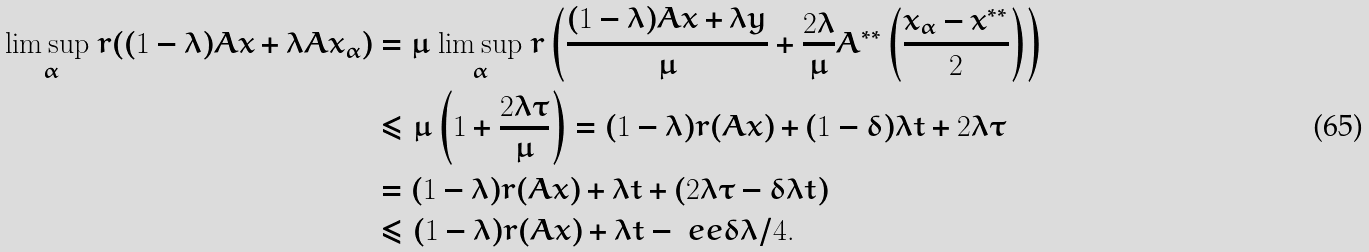<formula> <loc_0><loc_0><loc_500><loc_500>\underset { \alpha } { \lim \sup \ } r ( ( 1 - \lambda ) A x + \lambda A x _ { \alpha } ) & = \mu \underset { \alpha } { \ \lim \sup \ } r \left ( \frac { ( 1 - \lambda ) A x + \lambda y } { \mu } + \frac { 2 \lambda } { \mu } A ^ { * * } \left ( \frac { x _ { \alpha } - x ^ { * * } } { 2 } \right ) \right ) \\ & \leqslant \mu \left ( 1 + \frac { 2 \lambda \tau } { \mu } \right ) = ( 1 - \lambda ) r ( A x ) + ( 1 - \delta ) \lambda t + 2 \lambda \tau \\ & = ( 1 - \lambda ) r ( A x ) + \lambda t + ( 2 \lambda \tau - \delta \lambda t ) \\ & \leqslant ( 1 - \lambda ) r ( A x ) + \lambda t - \ e e \delta \lambda / 4 .</formula> 